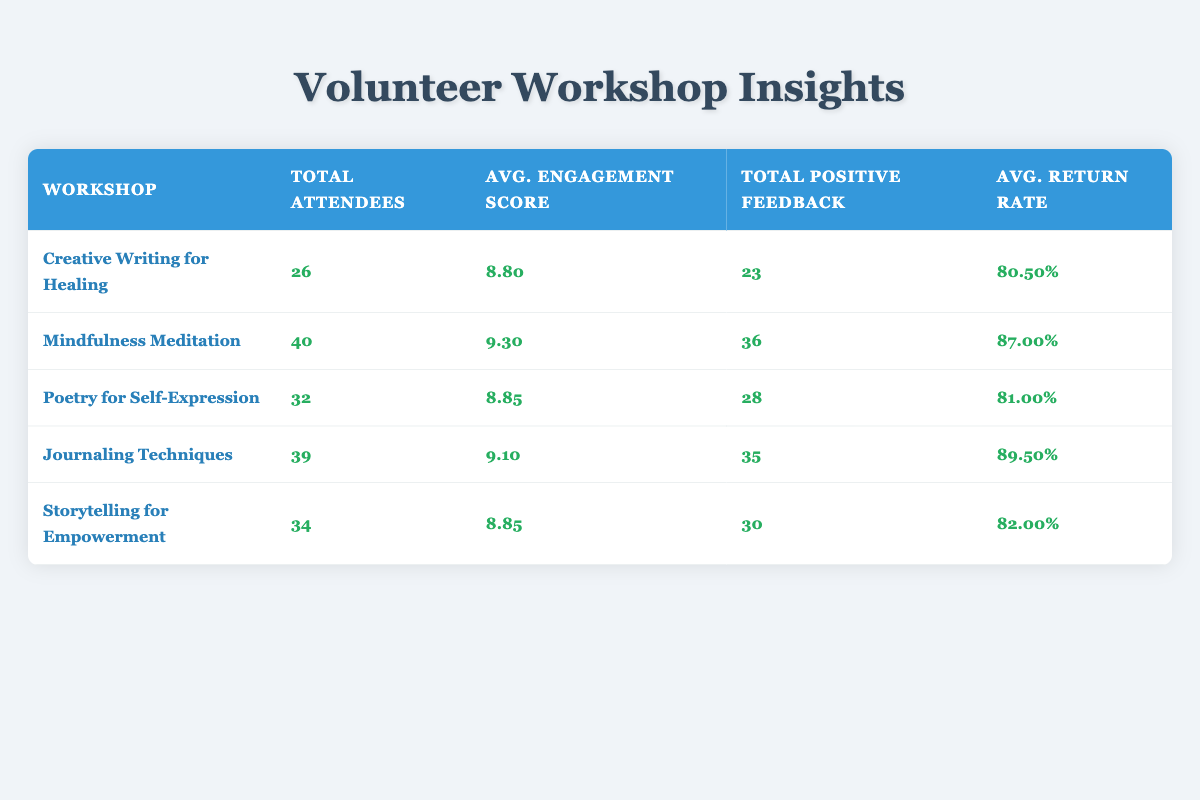What is the total number of attendees for the "Mindfulness Meditation" workshop? From the table, look for the row corresponding to "Mindfulness Meditation" workshop. The row shows that the total attendees are 40.
Answer: 40 What is the average engagement score of the "Poetry for Self-Expression" workshop? The table provides the engagement score for "Poetry for Self-Expression." The average is directly given as 8.85.
Answer: 8.85 Did "Creative Writing for Healing" have more positive feedback than "Journaling Techniques"? For "Creative Writing for Healing," the positive feedback is reported as 23. For "Journaling Techniques," it is 35. Since 23 is less than 35, the statement is false.
Answer: No What was the total positive feedback across all workshops? Summing up the total positive feedback from all workshops: 23 + 36 + 28 + 35 + 30 = 152.
Answer: 152 Which workshop had the highest average return rate? Looking at the return rates, “Journaling Techniques” has 89.50%, which is the highest among all the workshops, so it is the answer.
Answer: Journaling Techniques Calculate the difference between the total attendees of "Mindfulness Meditation" and "Creative Writing for Healing." Mindfulness Meditation has 40 attendees and Creative Writing for Healing has 26 attendees. The difference is 40 - 26 = 14.
Answer: 14 Is the engagement score of "Storytelling for Empowerment" higher than the overall average engagement score of all workshops? The engagement score of "Storytelling for Empowerment" is 8.85. To find the overall average, we sum all engagement scores and divide by the number of workshops: (8.80 + 9.30 + 8.85 + 9.10 + 8.85) / 5 = 8.80. The engagement score of "Storytelling for Empowerment" is higher than the overall average.
Answer: Yes What is the average return rate for all workshops? Calculating the average return rate entails summing the return rates: (80.50% + 87.00% + 81.00% + 89.50% + 82.00%) / 5 = 83.80%.
Answer: 83.80% Which workshop had the least total attendees? Comparing total attendees across all workshops reveals "Creative Writing for Healing" with a total of 26 attendees, the lowest among the groups.
Answer: Creative Writing for Healing 